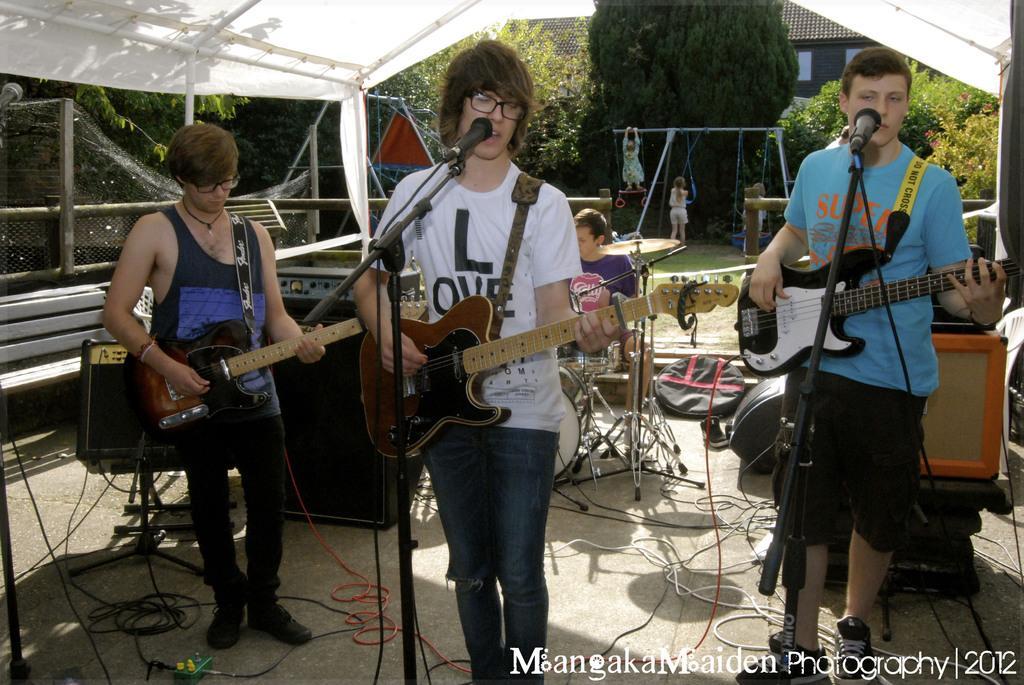Please provide a concise description of this image. The image is outside of the city. In the image there are three people holding a guitar and playing in front of a microphone. In background there is a man sitting on chair and two girls are playing and we can also see trees,building,windows which are closed. On left side there is a net fence and bench and speakers with wires on top there is a white color roof and at bottom there is a mat with few wires. 